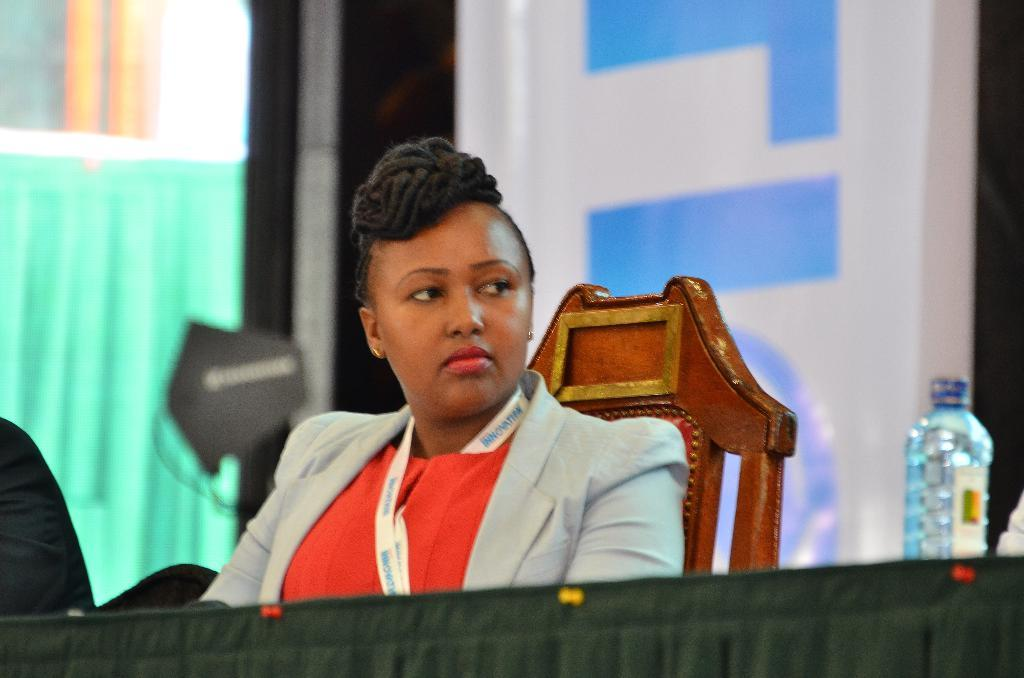Who is present in the image? There is a woman in the image. What is the woman doing in the image? The woman is sitting on a chair. What object can be seen on the table in the image? There is a water bottle on the table. What might the woman be using the chair for in the image? The woman might be using the chair for sitting or resting. What type of glue is the woman using to copy a document in the image? There is no glue or document present in the image, and the woman is not shown copying anything. 